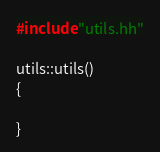<code> <loc_0><loc_0><loc_500><loc_500><_C++_>#include "utils.hh"

utils::utils()
{

}
</code> 